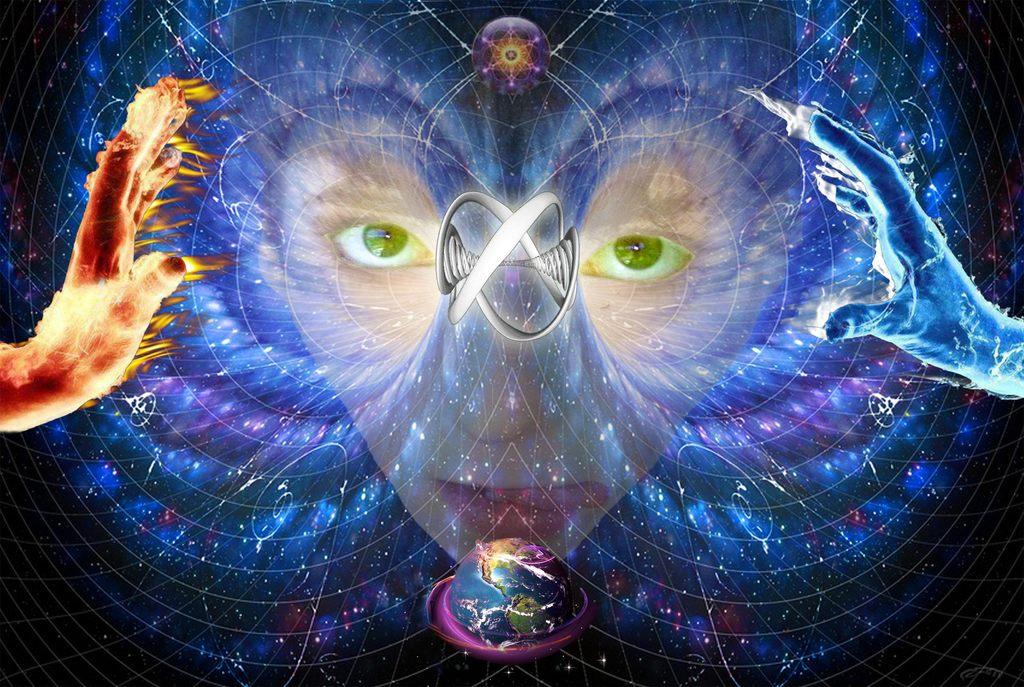What is the main subject of the animation? The animation features a person's face. What is depicted in the person's hands? The person's hands are depicted with fire. What natural element is illustrated in the animation? There is an illusion of water in the animation. What geographical feature is shown in the animation? The planet Earth is shown in the animation. How many socks are visible on the person's feet in the animation? There are no socks or feet visible in the animation; it features a person's face and hands. What type of pest can be seen crawling on the planet Earth in the animation? There are no pests present in the animation; it only features a person's face, hands with fire, an illusion of water, and the planet Earth. 